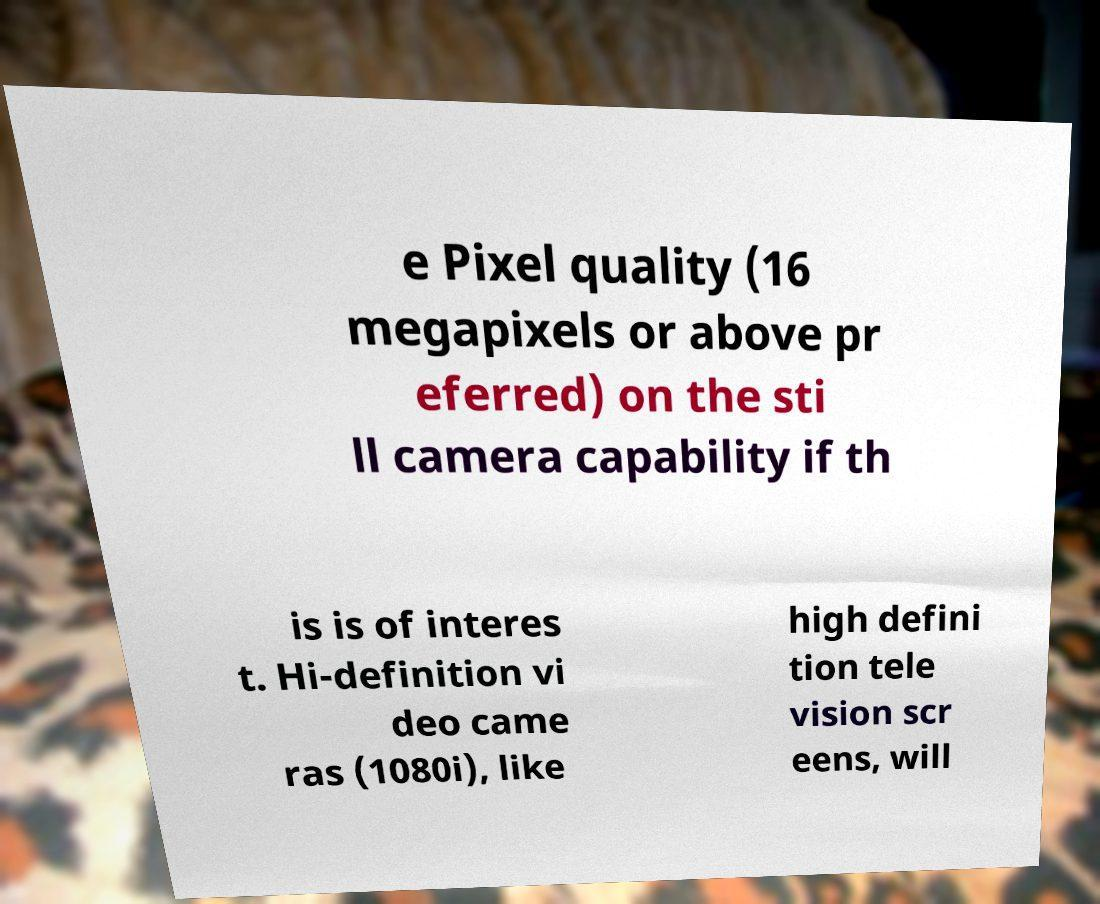There's text embedded in this image that I need extracted. Can you transcribe it verbatim? e Pixel quality (16 megapixels or above pr eferred) on the sti ll camera capability if th is is of interes t. Hi-definition vi deo came ras (1080i), like high defini tion tele vision scr eens, will 